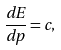<formula> <loc_0><loc_0><loc_500><loc_500>\frac { d E } { d p } = c ,</formula> 